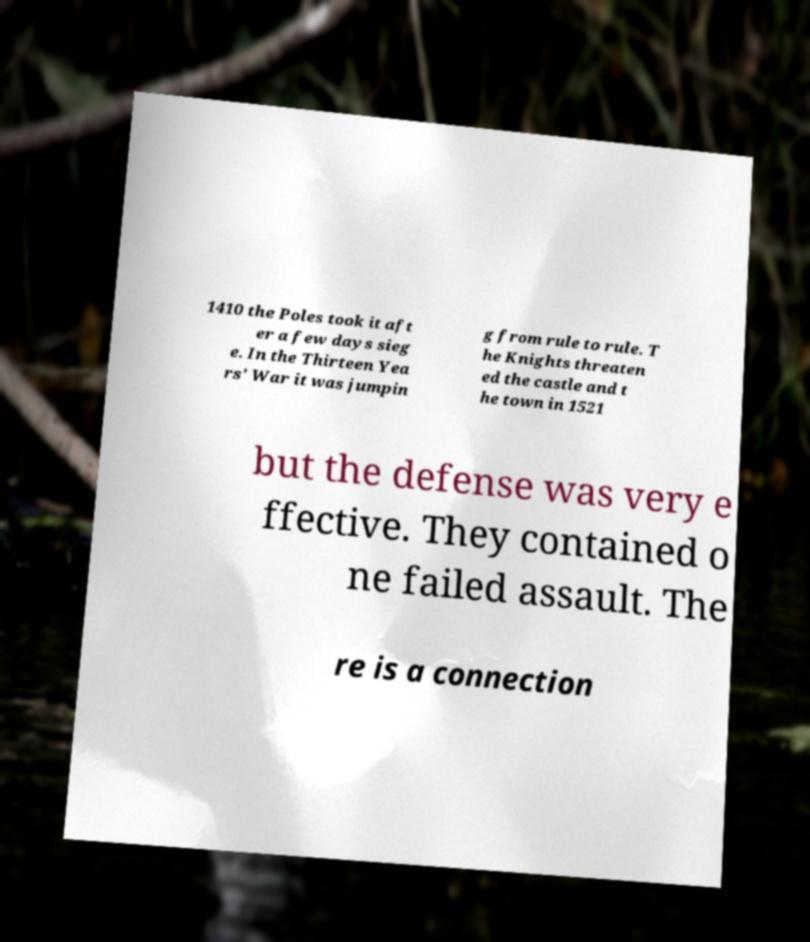Could you extract and type out the text from this image? 1410 the Poles took it aft er a few days sieg e. In the Thirteen Yea rs' War it was jumpin g from rule to rule. T he Knights threaten ed the castle and t he town in 1521 but the defense was very e ffective. They contained o ne failed assault. The re is a connection 